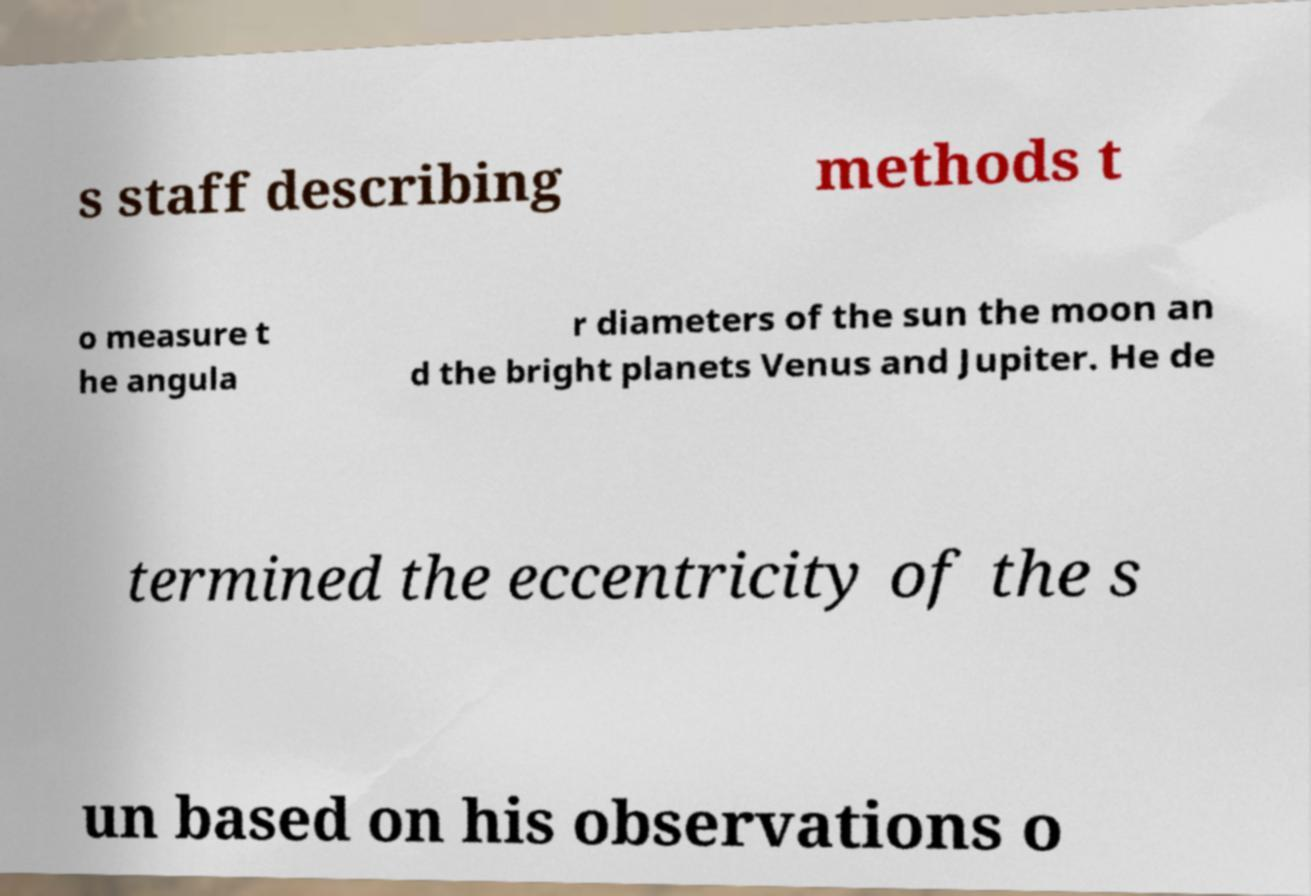Could you extract and type out the text from this image? s staff describing methods t o measure t he angula r diameters of the sun the moon an d the bright planets Venus and Jupiter. He de termined the eccentricity of the s un based on his observations o 